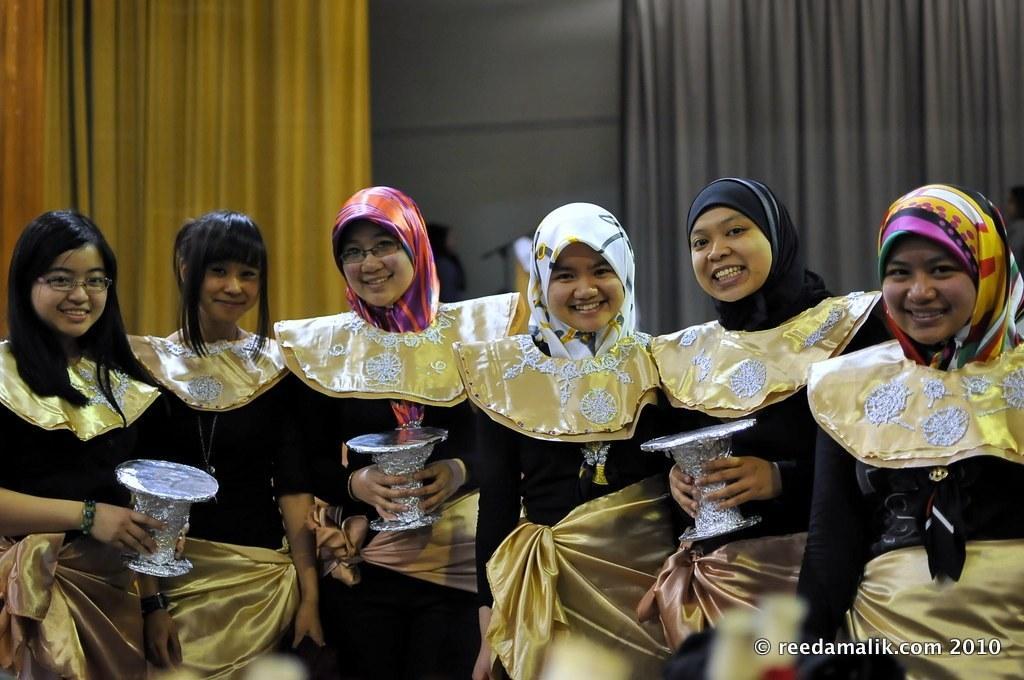Could you give a brief overview of what you see in this image? In this picture I can see six women who are wearing same dress and some girls are holding boxes. In the back I can see the yellow and grey color cloth which are placed near to the wall. In the bottom right corner there is a watermark. 